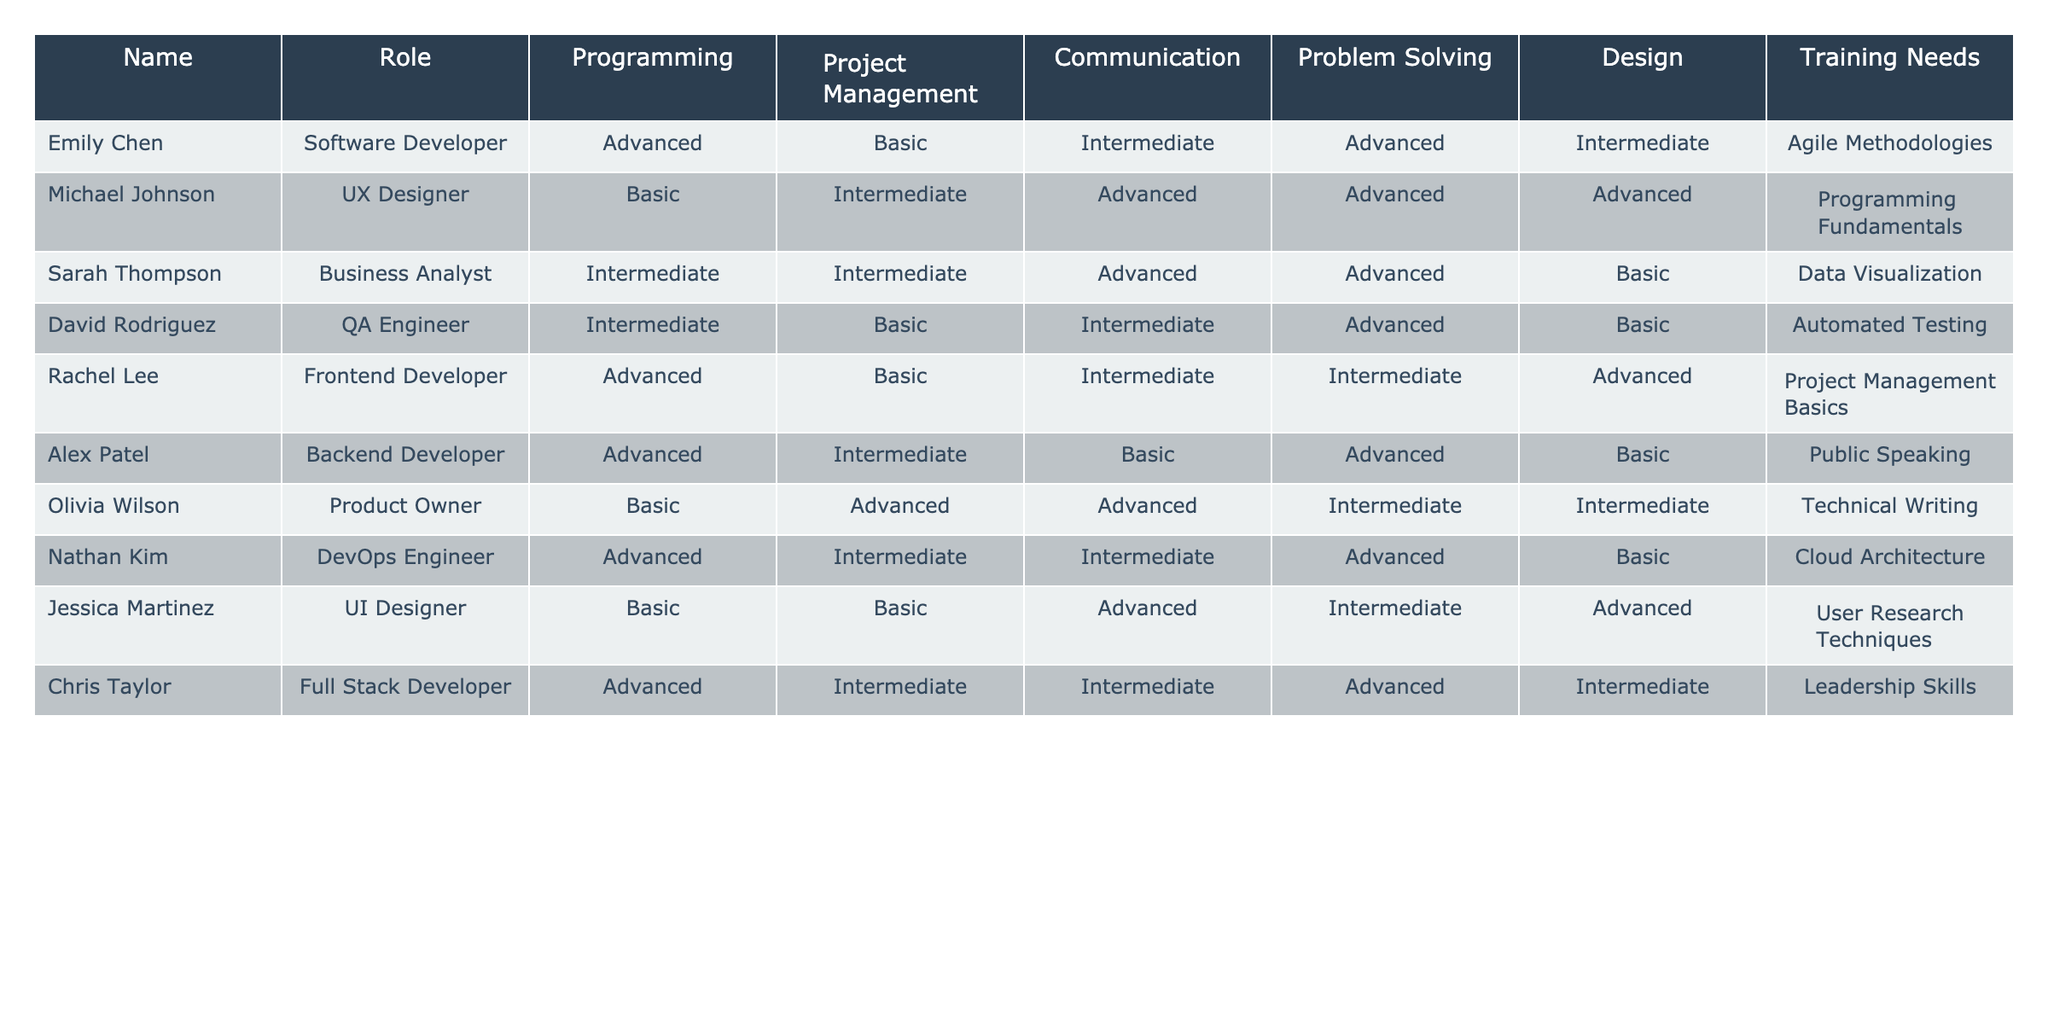What is Emily Chen's level in Project Management? According to the table, Emily Chen is listed as having a Basic level in Project Management.
Answer: Basic Which team members have Advanced skills in Design? The table shows that both Michael Johnson and Jessica Martinez are marked as Advanced in Design.
Answer: Michael Johnson, Jessica Martinez What is the training need for David Rodriguez? Looking at the table, David Rodriguez has a training need listed as Automated Testing.
Answer: Automated Testing How many team members have Intermediate skills in Communication? By counting the entries in the Communication column, Sarah Thompson, Rachel Lee, Chris Taylor have Intermediate skills, giving a total of three.
Answer: 3 Does Olivia Wilson have any training needs related to programming? The table shows that Olivia Wilson has a training need listed as Technical Writing, which is not related to programming, so the answer is no.
Answer: No What is the difference between the number of team members who have Advanced skills in Programming and those with Basic skills? Counting the Advanced skills in Programming gives four members (Emily Chen, Michael Johnson, Nathan Kim, Alex Patel), while Basic skills in Programming have two members (Michael Johnson, Jessica Martinez). The difference is 4 - 2 = 2.
Answer: 2 Which role has the highest average skill level across all categories? To find this, one must calculate the average for each role: Software Developer (3.5), UX Designer (3.6), Business Analyst (3.2), QA Engineer (2.8), Frontend Developer (3.4), Backend Developer (3.2), Product Owner (3.2), DevOps Engineer (3.4), UI Designer (3.2), Full Stack Developer (3.2). UX Designer has the highest average at 3.6.
Answer: UX Designer What proportion of team members are listed as having Basic skills in Problem Solving? There are 10 members total and three (David Rodriguez, Rachel Lee, Alex Patel) are marked as Basic in Problem Solving, thus the proportion is 3/10 or 30 percent.
Answer: 30 percent Which training need is shared by multiple roles? Reviewing the training needs in the table, both David Rodriguez and Alex Patel mention Automated Testing and Public Speaking respectively, thus there are no shared training needs among members.
Answer: None 